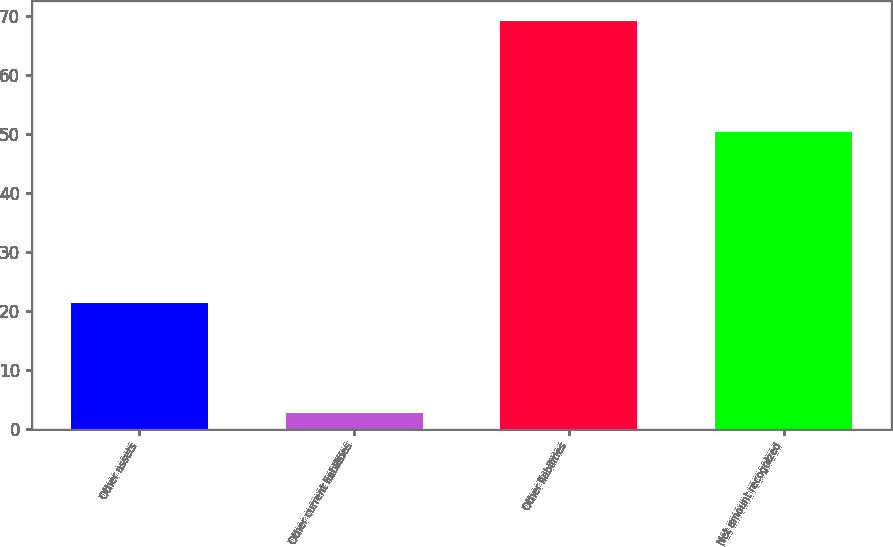Convert chart to OTSL. <chart><loc_0><loc_0><loc_500><loc_500><bar_chart><fcel>Other assets<fcel>Other current liabilities<fcel>Other liabilities<fcel>Net amount recognized<nl><fcel>21.4<fcel>2.7<fcel>69.1<fcel>50.4<nl></chart> 